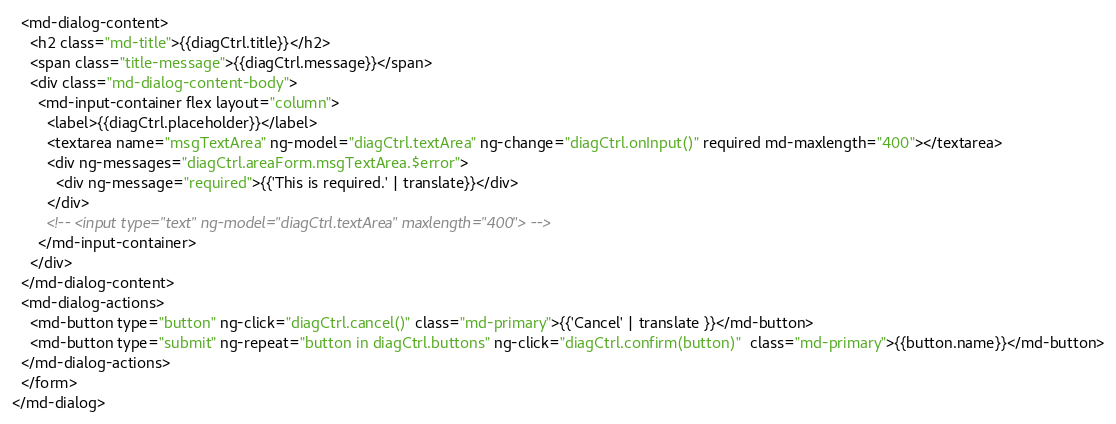<code> <loc_0><loc_0><loc_500><loc_500><_HTML_>  <md-dialog-content>
    <h2 class="md-title">{{diagCtrl.title}}</h2>
    <span class="title-message">{{diagCtrl.message}}</span>
    <div class="md-dialog-content-body">
      <md-input-container flex layout="column">
        <label>{{diagCtrl.placeholder}}</label>
        <textarea name="msgTextArea" ng-model="diagCtrl.textArea" ng-change="diagCtrl.onInput()" required md-maxlength="400"></textarea>
        <div ng-messages="diagCtrl.areaForm.msgTextArea.$error">
          <div ng-message="required">{{'This is required.' | translate}}</div>
        </div>
        <!-- <input type="text" ng-model="diagCtrl.textArea" maxlength="400"> -->
      </md-input-container>
    </div>
  </md-dialog-content>
  <md-dialog-actions>
    <md-button type="button" ng-click="diagCtrl.cancel()" class="md-primary">{{'Cancel' | translate }}</md-button>
    <md-button type="submit" ng-repeat="button in diagCtrl.buttons" ng-click="diagCtrl.confirm(button)"  class="md-primary">{{button.name}}</md-button>
  </md-dialog-actions>
  </form>
</md-dialog></code> 